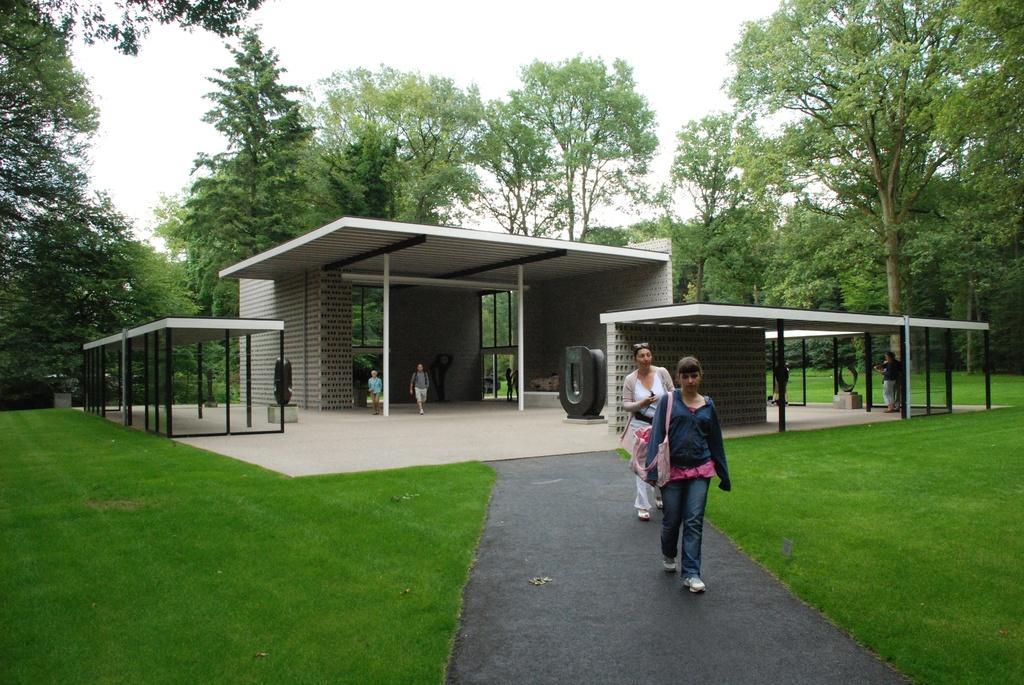In one or two sentences, can you explain what this image depicts? There is a construction and from that people are walking outside from the path and on the either side of the path there is a beautiful garden and around the garden there are some trees. 